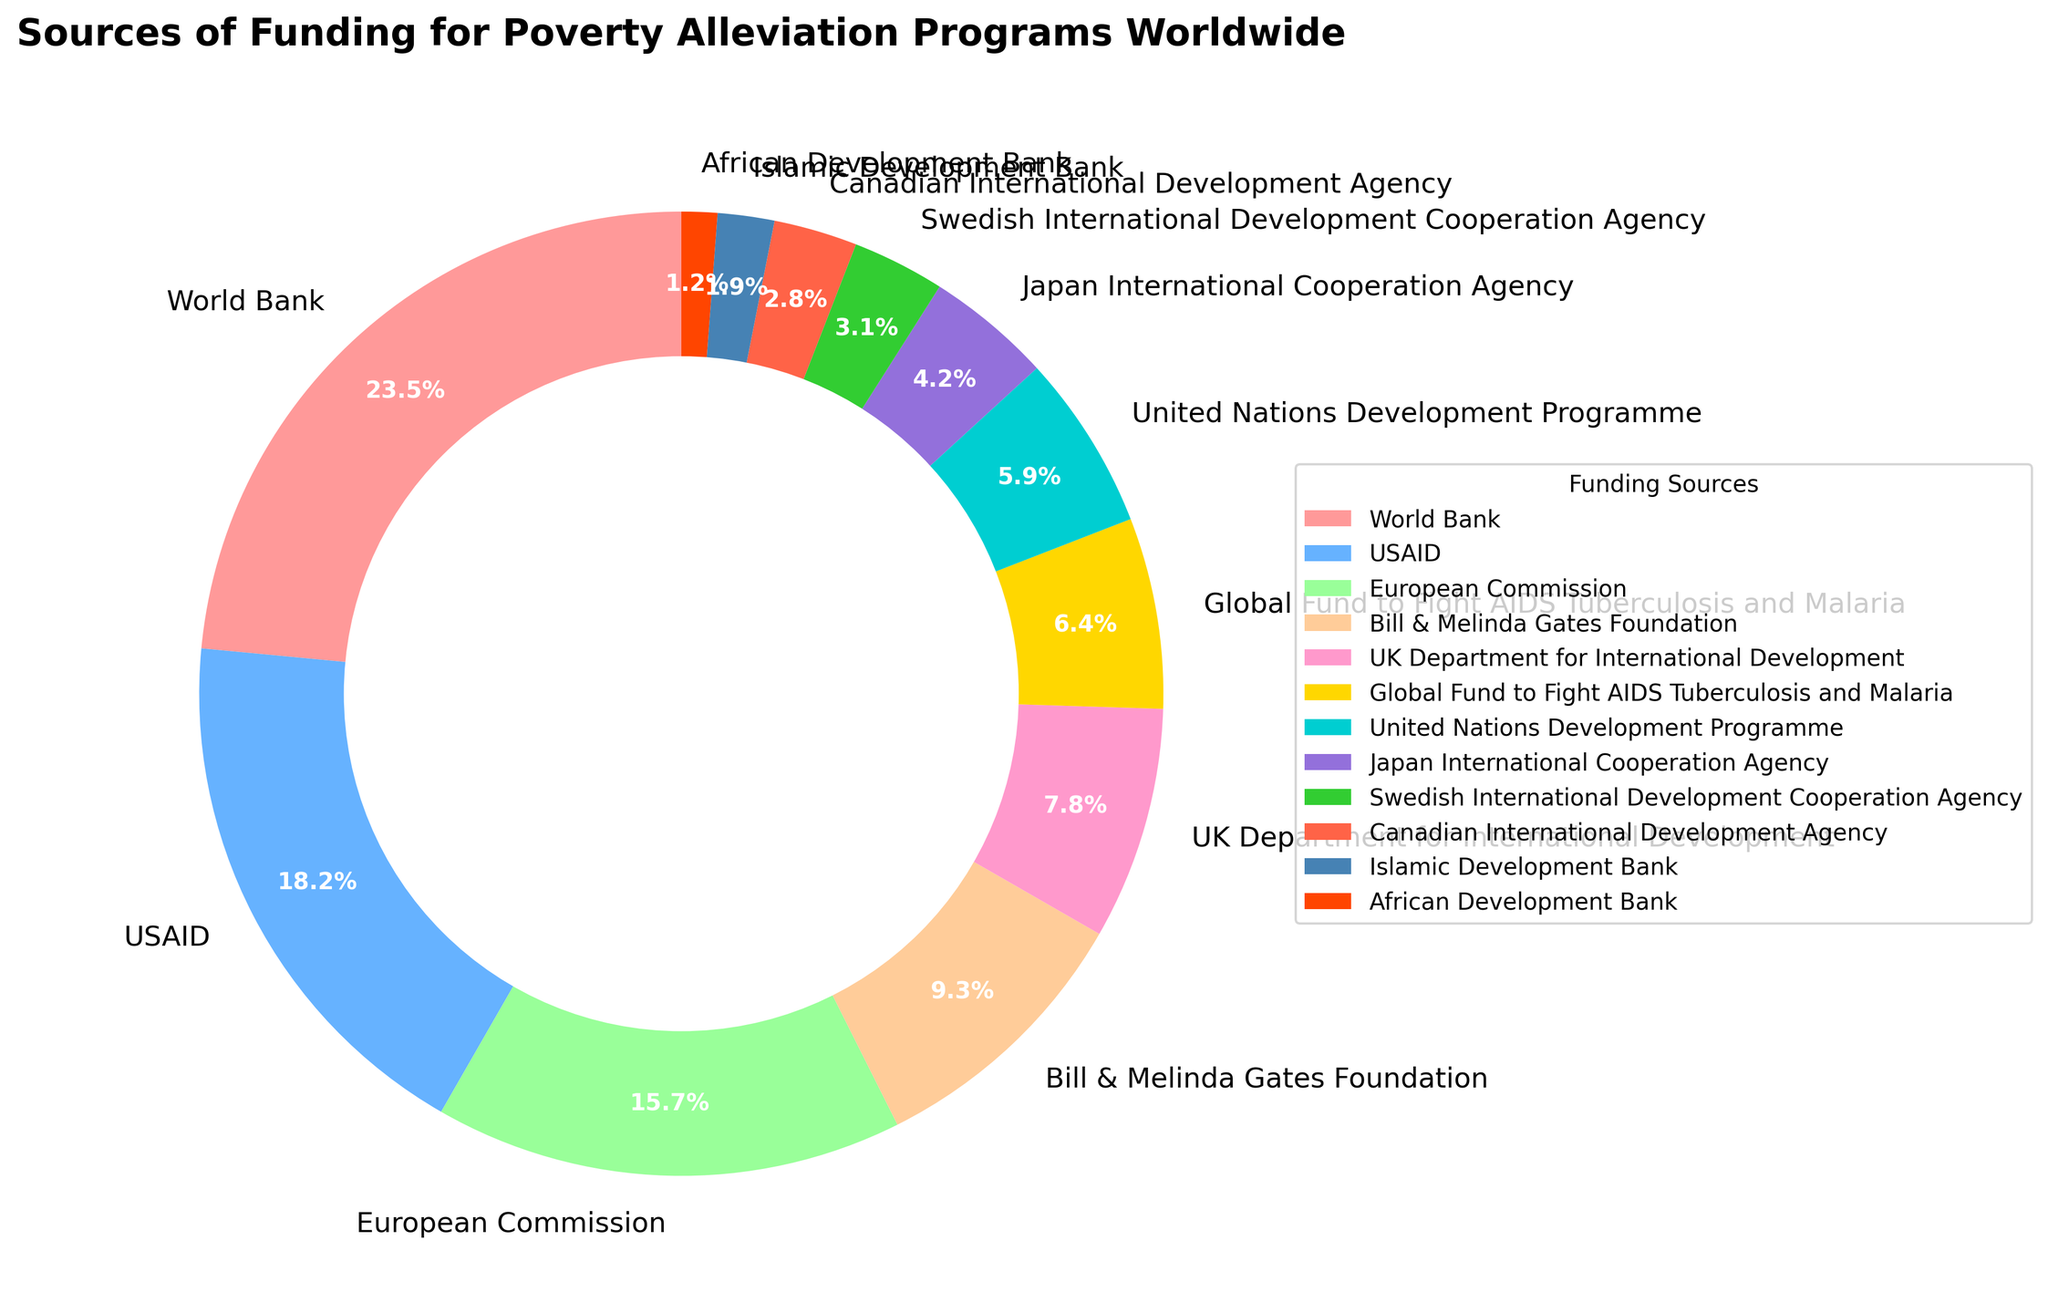What is the percentage contribution of the World Bank to poverty alleviation programs? Looking at the pie chart, we find the segment labeled with "World Bank." The percentage shown in this segment is 23.5%.
Answer: 23.5% Which funding source contributes the least percentage? By observing the pie chart, we find that the "African Development Bank" has the smallest segment, labeled with 1.2%.
Answer: African Development Bank How much higher is the contribution from USAID compared to the United Nations Development Programme? The percentage for USAID is 18.2% and for the United Nations Development Programme is 5.9%. The difference is calculated as 18.2% - 5.9% = 12.3%.
Answer: 12.3% What is the combined contribution of the European Commission and the Bill & Melinda Gates Foundation? The percentage for the European Commission is 15.7% and for the Bill & Melinda Gates Foundation is 9.3%. The sum of these contributions is 15.7% + 9.3% = 25%.
Answer: 25% Which funding source has a green-colored segment, and what is its percentage? The pie chart shows that the "United Nations Development Programme" has a green-colored segment, and its percentage is 5.9%.
Answer: United Nations Development Programme, 5.9% How much more does the World Bank contribute compared to the combined contributions of the Swedish International Development Cooperation Agency and the Canadian International Development Agency? The World Bank contributes 23.5%. The Swedish International Development Cooperation Agency contributes 3.1%, and the Canadian International Development Agency contributes 2.8%. Their combined contributions total 3.1% + 2.8% = 5.9%. The difference is 23.5% - 5.9% = 17.6%.
Answer: 17.6% How does the share of the UK Department for International Development compare to USAID? The percentage for the UK Department for International Development is 7.8%, while for USAID it is 18.2%. The UK Department for International Development's share is less than USAID by 18.2% - 7.8% = 10.4%.
Answer: 10.4% less Which funding sources collectively contribute more than 50% of total funding? The contributions from the World Bank, USAID, and the European Commission are 23.5%, 18.2%, and 15.7% respectively. Adding these gives 23.5% + 18.2% + 15.7% = 57.4%, which is more than 50%.
Answer: World Bank, USAID, European Commission What is the average percentage contribution of the top three funding sources? The top three funding sources are the World Bank (23.5%), USAID (18.2%), and the European Commission (15.7%). The average is calculated as (23.5% + 18.2% + 15.7%) / 3 = 19.13%.
Answer: 19.13% 